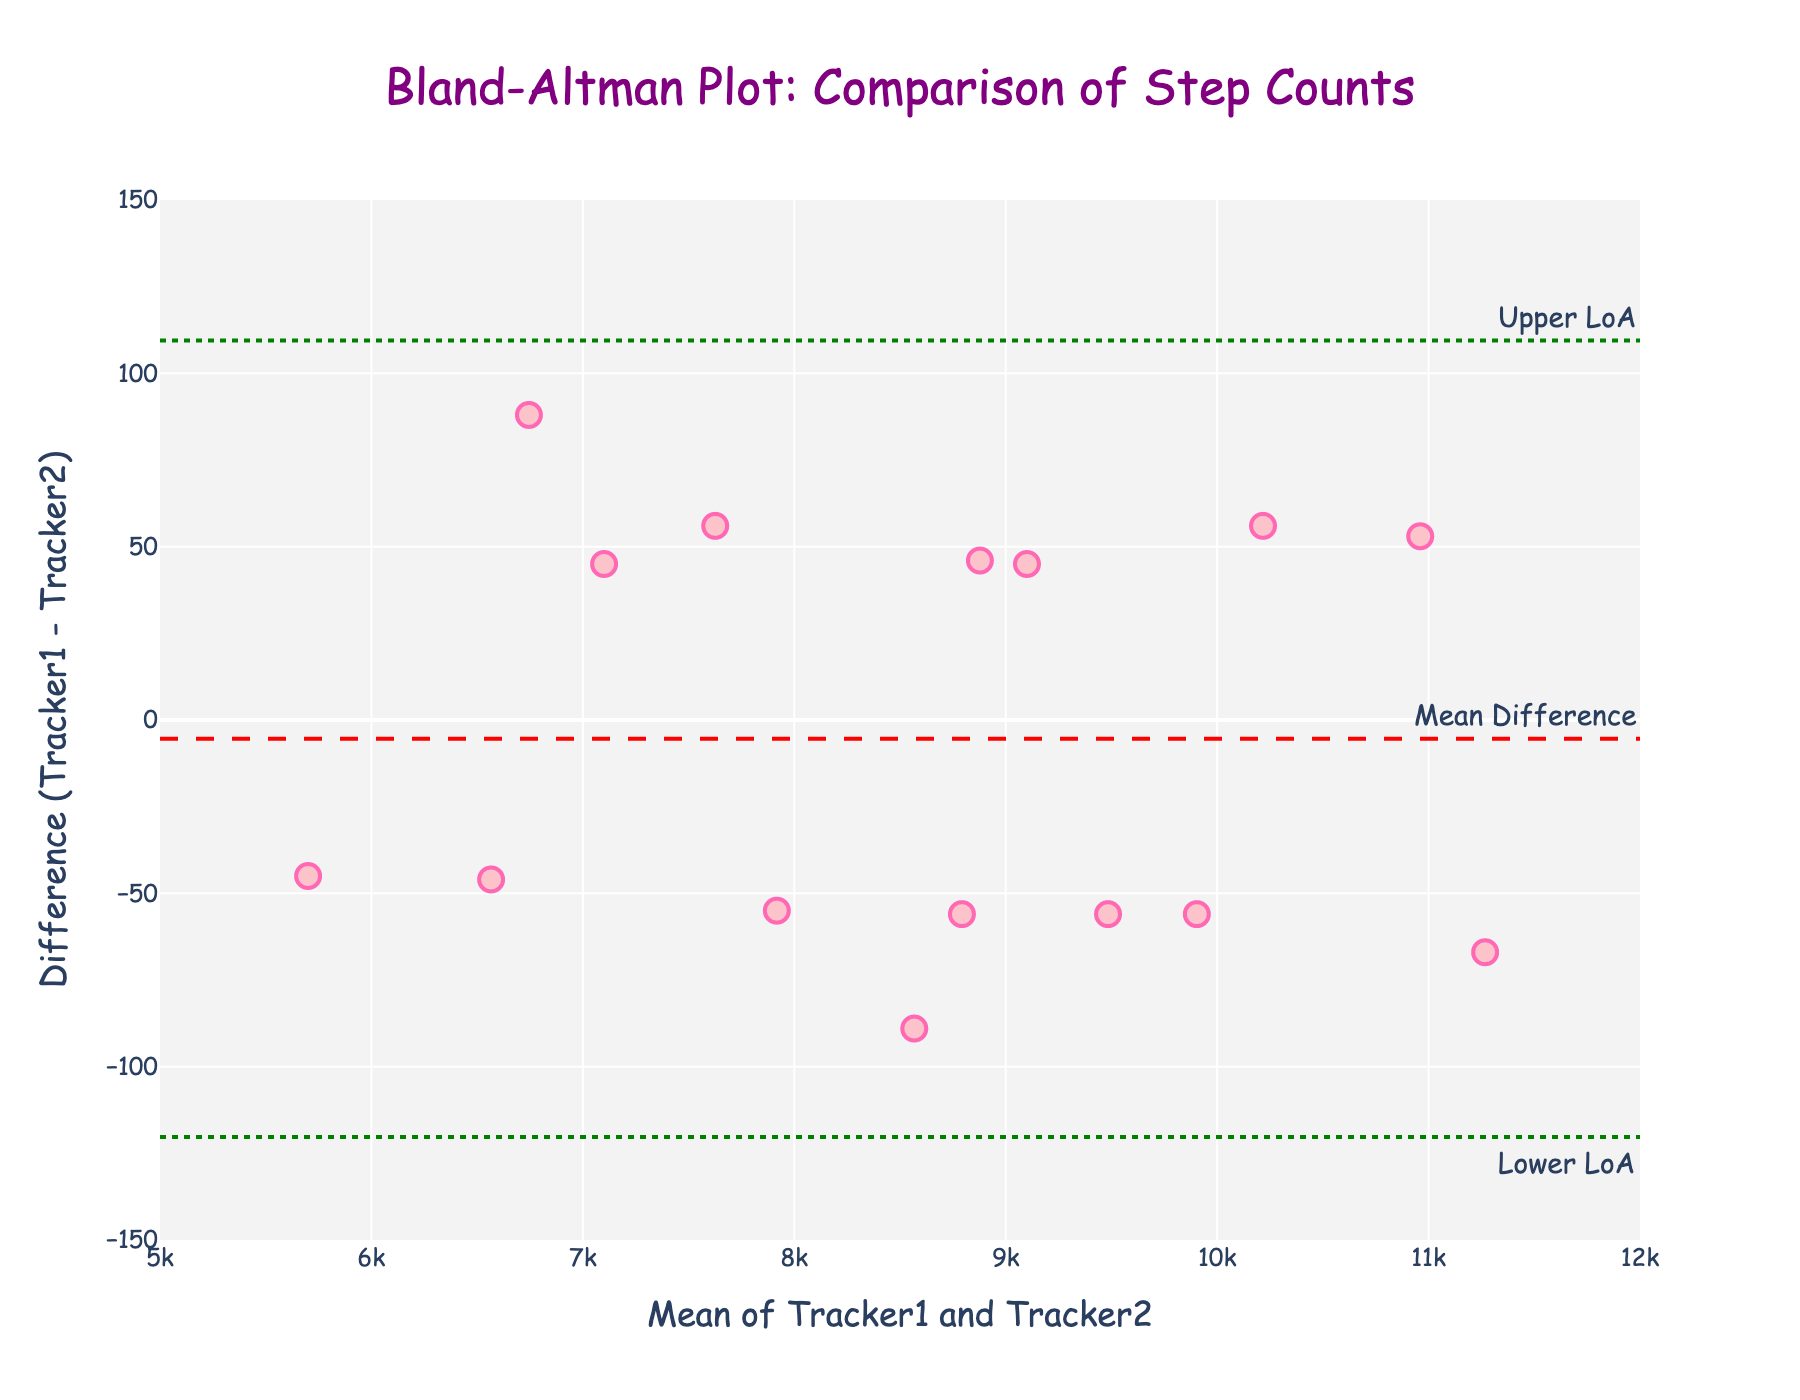What is the title of the plot? The title is displayed at the top of the plot and reads "Bland-Altman Plot: Comparison of Step Counts." Just by looking at the top area of the figure, you can see this text.
Answer: Bland-Altman Plot: Comparison of Step Counts What do the x-axis and y-axis represent? The x-axis represents the mean of step counts from Tracker1 and Tracker2, labeled as "Mean of Tracker1 and Tracker2." The y-axis represents the difference in step counts between Tracker1 and Tracker2, labeled as "Difference (Tracker1 - Tracker2)." This information is displayed near the corresponding axes.
Answer: Mean of Tracker1 and Tracker2; Difference (Tracker1 - Tracker2) How many data points are there in the plot? You can determine the number of data points by counting the markers shown in the plot. Each marker represents one pair of step counts from the two trackers.
Answer: 15 What is the color of the data points? By looking at the scatter markers in the plot, you can note the color, which is a shade of pink.
Answer: Pink What is the mean difference line's y-value? The mean difference line is marked with a dashed red line and labeled "Mean Difference." You can read the y-value directly from the plot’s annotation text.
Answer: 1.2 What are the y-values of the Upper and Lower Limits of Agreement? The Upper and Lower Limits of Agreement are indicated by dotted green lines labeled "Upper LoA" and "Lower LoA." Read the y-values directly from the annotations.
Answer: 74.1; -71.7 Which axes range from 5000 to 12000? The range of the x-axis is displayed in the bottom part of the plot, showing it goes from 5000 to 12000. You can confirm this by looking at the tick marks.
Answer: x-axis How do the majority of the data points relate to the y=0 line? Most data points are distributed around the y=0 line but do not lie exactly on it. You can observe whether the data points are above, below, or close to the y=0 line throughout the plot.
Answer: Around y=0 line What is the range of difference values for the plot? The y-axis shows the difference between Tracker1 and Tracker2, ranging from roughly -150 to 150. This range is indicated by the axis tick marks.
Answer: -150 to 150 